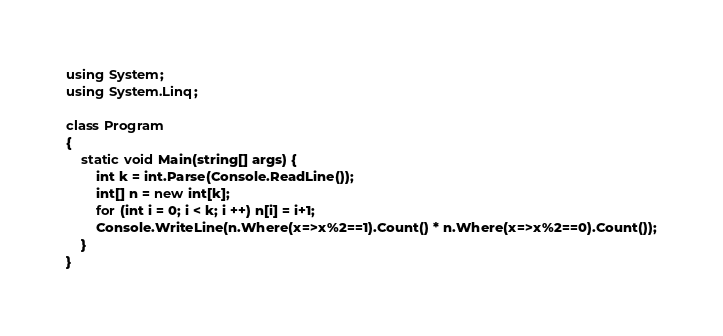<code> <loc_0><loc_0><loc_500><loc_500><_C#_>using System;
using System.Linq;

class Program
{
    static void Main(string[] args) {
        int k = int.Parse(Console.ReadLine());
        int[] n = new int[k];
        for (int i = 0; i < k; i ++) n[i] = i+1;
        Console.WriteLine(n.Where(x=>x%2==1).Count() * n.Where(x=>x%2==0).Count());
    }
}</code> 